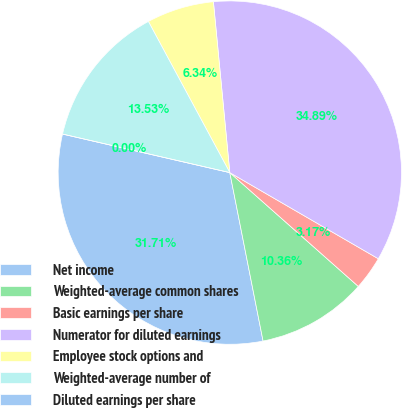<chart> <loc_0><loc_0><loc_500><loc_500><pie_chart><fcel>Net income<fcel>Weighted-average common shares<fcel>Basic earnings per share<fcel>Numerator for diluted earnings<fcel>Employee stock options and<fcel>Weighted-average number of<fcel>Diluted earnings per share<nl><fcel>31.71%<fcel>10.36%<fcel>3.17%<fcel>34.89%<fcel>6.34%<fcel>13.53%<fcel>0.0%<nl></chart> 